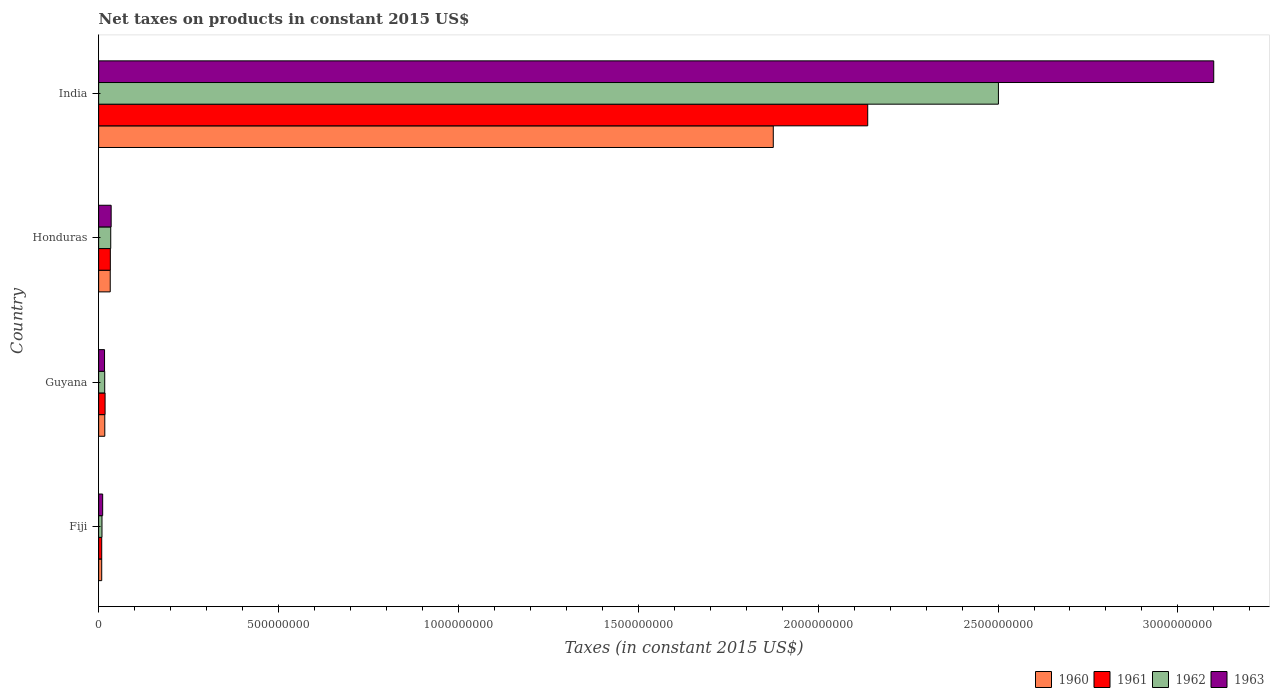How many groups of bars are there?
Offer a terse response. 4. Are the number of bars per tick equal to the number of legend labels?
Your answer should be very brief. Yes. Are the number of bars on each tick of the Y-axis equal?
Provide a succinct answer. Yes. How many bars are there on the 1st tick from the top?
Provide a short and direct response. 4. How many bars are there on the 3rd tick from the bottom?
Make the answer very short. 4. What is the label of the 3rd group of bars from the top?
Provide a succinct answer. Guyana. In how many cases, is the number of bars for a given country not equal to the number of legend labels?
Give a very brief answer. 0. What is the net taxes on products in 1963 in India?
Your response must be concise. 3.10e+09. Across all countries, what is the maximum net taxes on products in 1961?
Provide a succinct answer. 2.14e+09. Across all countries, what is the minimum net taxes on products in 1962?
Your response must be concise. 9.32e+06. In which country was the net taxes on products in 1960 maximum?
Your answer should be very brief. India. In which country was the net taxes on products in 1960 minimum?
Offer a very short reply. Fiji. What is the total net taxes on products in 1960 in the graph?
Offer a very short reply. 1.93e+09. What is the difference between the net taxes on products in 1962 in Guyana and that in India?
Make the answer very short. -2.48e+09. What is the difference between the net taxes on products in 1962 in Guyana and the net taxes on products in 1961 in Fiji?
Make the answer very short. 8.35e+06. What is the average net taxes on products in 1962 per country?
Your answer should be compact. 6.40e+08. What is the difference between the net taxes on products in 1963 and net taxes on products in 1961 in Honduras?
Your response must be concise. 2.30e+06. In how many countries, is the net taxes on products in 1962 greater than 1100000000 US$?
Offer a very short reply. 1. What is the ratio of the net taxes on products in 1963 in Fiji to that in Honduras?
Ensure brevity in your answer.  0.32. Is the net taxes on products in 1960 in Guyana less than that in Honduras?
Your answer should be compact. Yes. What is the difference between the highest and the second highest net taxes on products in 1962?
Your response must be concise. 2.47e+09. What is the difference between the highest and the lowest net taxes on products in 1963?
Provide a short and direct response. 3.09e+09. In how many countries, is the net taxes on products in 1962 greater than the average net taxes on products in 1962 taken over all countries?
Give a very brief answer. 1. Is the sum of the net taxes on products in 1961 in Fiji and Guyana greater than the maximum net taxes on products in 1963 across all countries?
Offer a terse response. No. Is it the case that in every country, the sum of the net taxes on products in 1961 and net taxes on products in 1962 is greater than the sum of net taxes on products in 1960 and net taxes on products in 1963?
Your response must be concise. No. What does the 4th bar from the top in India represents?
Ensure brevity in your answer.  1960. How many countries are there in the graph?
Your response must be concise. 4. Does the graph contain any zero values?
Make the answer very short. No. Does the graph contain grids?
Offer a terse response. No. How many legend labels are there?
Provide a succinct answer. 4. How are the legend labels stacked?
Give a very brief answer. Horizontal. What is the title of the graph?
Provide a succinct answer. Net taxes on products in constant 2015 US$. What is the label or title of the X-axis?
Provide a succinct answer. Taxes (in constant 2015 US$). What is the Taxes (in constant 2015 US$) of 1960 in Fiji?
Your answer should be compact. 8.56e+06. What is the Taxes (in constant 2015 US$) in 1961 in Fiji?
Offer a very short reply. 8.56e+06. What is the Taxes (in constant 2015 US$) in 1962 in Fiji?
Provide a short and direct response. 9.32e+06. What is the Taxes (in constant 2015 US$) in 1963 in Fiji?
Offer a very short reply. 1.12e+07. What is the Taxes (in constant 2015 US$) in 1960 in Guyana?
Your response must be concise. 1.71e+07. What is the Taxes (in constant 2015 US$) of 1961 in Guyana?
Offer a terse response. 1.79e+07. What is the Taxes (in constant 2015 US$) in 1962 in Guyana?
Your answer should be compact. 1.69e+07. What is the Taxes (in constant 2015 US$) of 1963 in Guyana?
Make the answer very short. 1.64e+07. What is the Taxes (in constant 2015 US$) of 1960 in Honduras?
Provide a short and direct response. 3.22e+07. What is the Taxes (in constant 2015 US$) of 1961 in Honduras?
Give a very brief answer. 3.25e+07. What is the Taxes (in constant 2015 US$) of 1962 in Honduras?
Offer a very short reply. 3.36e+07. What is the Taxes (in constant 2015 US$) of 1963 in Honduras?
Keep it short and to the point. 3.48e+07. What is the Taxes (in constant 2015 US$) in 1960 in India?
Provide a short and direct response. 1.88e+09. What is the Taxes (in constant 2015 US$) in 1961 in India?
Offer a terse response. 2.14e+09. What is the Taxes (in constant 2015 US$) of 1962 in India?
Keep it short and to the point. 2.50e+09. What is the Taxes (in constant 2015 US$) of 1963 in India?
Your answer should be very brief. 3.10e+09. Across all countries, what is the maximum Taxes (in constant 2015 US$) in 1960?
Give a very brief answer. 1.88e+09. Across all countries, what is the maximum Taxes (in constant 2015 US$) of 1961?
Keep it short and to the point. 2.14e+09. Across all countries, what is the maximum Taxes (in constant 2015 US$) in 1962?
Ensure brevity in your answer.  2.50e+09. Across all countries, what is the maximum Taxes (in constant 2015 US$) in 1963?
Your response must be concise. 3.10e+09. Across all countries, what is the minimum Taxes (in constant 2015 US$) in 1960?
Offer a terse response. 8.56e+06. Across all countries, what is the minimum Taxes (in constant 2015 US$) of 1961?
Your answer should be very brief. 8.56e+06. Across all countries, what is the minimum Taxes (in constant 2015 US$) of 1962?
Offer a very short reply. 9.32e+06. Across all countries, what is the minimum Taxes (in constant 2015 US$) in 1963?
Provide a succinct answer. 1.12e+07. What is the total Taxes (in constant 2015 US$) of 1960 in the graph?
Offer a terse response. 1.93e+09. What is the total Taxes (in constant 2015 US$) of 1961 in the graph?
Give a very brief answer. 2.20e+09. What is the total Taxes (in constant 2015 US$) of 1962 in the graph?
Your response must be concise. 2.56e+09. What is the total Taxes (in constant 2015 US$) in 1963 in the graph?
Offer a very short reply. 3.16e+09. What is the difference between the Taxes (in constant 2015 US$) of 1960 in Fiji and that in Guyana?
Provide a short and direct response. -8.59e+06. What is the difference between the Taxes (in constant 2015 US$) of 1961 in Fiji and that in Guyana?
Offer a very short reply. -9.34e+06. What is the difference between the Taxes (in constant 2015 US$) in 1962 in Fiji and that in Guyana?
Ensure brevity in your answer.  -7.60e+06. What is the difference between the Taxes (in constant 2015 US$) in 1963 in Fiji and that in Guyana?
Make the answer very short. -5.24e+06. What is the difference between the Taxes (in constant 2015 US$) of 1960 in Fiji and that in Honduras?
Keep it short and to the point. -2.37e+07. What is the difference between the Taxes (in constant 2015 US$) in 1961 in Fiji and that in Honduras?
Your answer should be very brief. -2.39e+07. What is the difference between the Taxes (in constant 2015 US$) of 1962 in Fiji and that in Honduras?
Your answer should be very brief. -2.43e+07. What is the difference between the Taxes (in constant 2015 US$) in 1963 in Fiji and that in Honduras?
Offer a terse response. -2.36e+07. What is the difference between the Taxes (in constant 2015 US$) of 1960 in Fiji and that in India?
Provide a short and direct response. -1.87e+09. What is the difference between the Taxes (in constant 2015 US$) of 1961 in Fiji and that in India?
Give a very brief answer. -2.13e+09. What is the difference between the Taxes (in constant 2015 US$) of 1962 in Fiji and that in India?
Your response must be concise. -2.49e+09. What is the difference between the Taxes (in constant 2015 US$) of 1963 in Fiji and that in India?
Keep it short and to the point. -3.09e+09. What is the difference between the Taxes (in constant 2015 US$) of 1960 in Guyana and that in Honduras?
Your answer should be very brief. -1.51e+07. What is the difference between the Taxes (in constant 2015 US$) of 1961 in Guyana and that in Honduras?
Your answer should be compact. -1.46e+07. What is the difference between the Taxes (in constant 2015 US$) in 1962 in Guyana and that in Honduras?
Your response must be concise. -1.67e+07. What is the difference between the Taxes (in constant 2015 US$) in 1963 in Guyana and that in Honduras?
Your answer should be compact. -1.84e+07. What is the difference between the Taxes (in constant 2015 US$) in 1960 in Guyana and that in India?
Your answer should be very brief. -1.86e+09. What is the difference between the Taxes (in constant 2015 US$) in 1961 in Guyana and that in India?
Ensure brevity in your answer.  -2.12e+09. What is the difference between the Taxes (in constant 2015 US$) of 1962 in Guyana and that in India?
Keep it short and to the point. -2.48e+09. What is the difference between the Taxes (in constant 2015 US$) in 1963 in Guyana and that in India?
Keep it short and to the point. -3.08e+09. What is the difference between the Taxes (in constant 2015 US$) of 1960 in Honduras and that in India?
Keep it short and to the point. -1.84e+09. What is the difference between the Taxes (in constant 2015 US$) of 1961 in Honduras and that in India?
Keep it short and to the point. -2.11e+09. What is the difference between the Taxes (in constant 2015 US$) of 1962 in Honduras and that in India?
Offer a very short reply. -2.47e+09. What is the difference between the Taxes (in constant 2015 US$) of 1963 in Honduras and that in India?
Your response must be concise. -3.06e+09. What is the difference between the Taxes (in constant 2015 US$) in 1960 in Fiji and the Taxes (in constant 2015 US$) in 1961 in Guyana?
Your answer should be compact. -9.34e+06. What is the difference between the Taxes (in constant 2015 US$) of 1960 in Fiji and the Taxes (in constant 2015 US$) of 1962 in Guyana?
Offer a terse response. -8.35e+06. What is the difference between the Taxes (in constant 2015 US$) in 1960 in Fiji and the Taxes (in constant 2015 US$) in 1963 in Guyana?
Make the answer very short. -7.89e+06. What is the difference between the Taxes (in constant 2015 US$) in 1961 in Fiji and the Taxes (in constant 2015 US$) in 1962 in Guyana?
Give a very brief answer. -8.35e+06. What is the difference between the Taxes (in constant 2015 US$) of 1961 in Fiji and the Taxes (in constant 2015 US$) of 1963 in Guyana?
Your answer should be very brief. -7.89e+06. What is the difference between the Taxes (in constant 2015 US$) in 1962 in Fiji and the Taxes (in constant 2015 US$) in 1963 in Guyana?
Provide a succinct answer. -7.13e+06. What is the difference between the Taxes (in constant 2015 US$) of 1960 in Fiji and the Taxes (in constant 2015 US$) of 1961 in Honduras?
Your answer should be very brief. -2.39e+07. What is the difference between the Taxes (in constant 2015 US$) in 1960 in Fiji and the Taxes (in constant 2015 US$) in 1962 in Honduras?
Your answer should be compact. -2.51e+07. What is the difference between the Taxes (in constant 2015 US$) in 1960 in Fiji and the Taxes (in constant 2015 US$) in 1963 in Honduras?
Give a very brief answer. -2.62e+07. What is the difference between the Taxes (in constant 2015 US$) of 1961 in Fiji and the Taxes (in constant 2015 US$) of 1962 in Honduras?
Offer a very short reply. -2.51e+07. What is the difference between the Taxes (in constant 2015 US$) of 1961 in Fiji and the Taxes (in constant 2015 US$) of 1963 in Honduras?
Provide a succinct answer. -2.62e+07. What is the difference between the Taxes (in constant 2015 US$) in 1962 in Fiji and the Taxes (in constant 2015 US$) in 1963 in Honduras?
Provide a succinct answer. -2.55e+07. What is the difference between the Taxes (in constant 2015 US$) in 1960 in Fiji and the Taxes (in constant 2015 US$) in 1961 in India?
Make the answer very short. -2.13e+09. What is the difference between the Taxes (in constant 2015 US$) of 1960 in Fiji and the Taxes (in constant 2015 US$) of 1962 in India?
Ensure brevity in your answer.  -2.49e+09. What is the difference between the Taxes (in constant 2015 US$) of 1960 in Fiji and the Taxes (in constant 2015 US$) of 1963 in India?
Give a very brief answer. -3.09e+09. What is the difference between the Taxes (in constant 2015 US$) of 1961 in Fiji and the Taxes (in constant 2015 US$) of 1962 in India?
Offer a very short reply. -2.49e+09. What is the difference between the Taxes (in constant 2015 US$) in 1961 in Fiji and the Taxes (in constant 2015 US$) in 1963 in India?
Keep it short and to the point. -3.09e+09. What is the difference between the Taxes (in constant 2015 US$) of 1962 in Fiji and the Taxes (in constant 2015 US$) of 1963 in India?
Give a very brief answer. -3.09e+09. What is the difference between the Taxes (in constant 2015 US$) of 1960 in Guyana and the Taxes (in constant 2015 US$) of 1961 in Honduras?
Your response must be concise. -1.54e+07. What is the difference between the Taxes (in constant 2015 US$) in 1960 in Guyana and the Taxes (in constant 2015 US$) in 1962 in Honduras?
Your answer should be very brief. -1.65e+07. What is the difference between the Taxes (in constant 2015 US$) of 1960 in Guyana and the Taxes (in constant 2015 US$) of 1963 in Honduras?
Your answer should be very brief. -1.77e+07. What is the difference between the Taxes (in constant 2015 US$) of 1961 in Guyana and the Taxes (in constant 2015 US$) of 1962 in Honduras?
Ensure brevity in your answer.  -1.57e+07. What is the difference between the Taxes (in constant 2015 US$) of 1961 in Guyana and the Taxes (in constant 2015 US$) of 1963 in Honduras?
Offer a terse response. -1.69e+07. What is the difference between the Taxes (in constant 2015 US$) in 1962 in Guyana and the Taxes (in constant 2015 US$) in 1963 in Honduras?
Your answer should be very brief. -1.79e+07. What is the difference between the Taxes (in constant 2015 US$) of 1960 in Guyana and the Taxes (in constant 2015 US$) of 1961 in India?
Your answer should be compact. -2.12e+09. What is the difference between the Taxes (in constant 2015 US$) of 1960 in Guyana and the Taxes (in constant 2015 US$) of 1962 in India?
Your response must be concise. -2.48e+09. What is the difference between the Taxes (in constant 2015 US$) in 1960 in Guyana and the Taxes (in constant 2015 US$) in 1963 in India?
Offer a terse response. -3.08e+09. What is the difference between the Taxes (in constant 2015 US$) of 1961 in Guyana and the Taxes (in constant 2015 US$) of 1962 in India?
Provide a short and direct response. -2.48e+09. What is the difference between the Taxes (in constant 2015 US$) of 1961 in Guyana and the Taxes (in constant 2015 US$) of 1963 in India?
Ensure brevity in your answer.  -3.08e+09. What is the difference between the Taxes (in constant 2015 US$) of 1962 in Guyana and the Taxes (in constant 2015 US$) of 1963 in India?
Provide a short and direct response. -3.08e+09. What is the difference between the Taxes (in constant 2015 US$) of 1960 in Honduras and the Taxes (in constant 2015 US$) of 1961 in India?
Your response must be concise. -2.11e+09. What is the difference between the Taxes (in constant 2015 US$) in 1960 in Honduras and the Taxes (in constant 2015 US$) in 1962 in India?
Give a very brief answer. -2.47e+09. What is the difference between the Taxes (in constant 2015 US$) of 1960 in Honduras and the Taxes (in constant 2015 US$) of 1963 in India?
Your answer should be compact. -3.07e+09. What is the difference between the Taxes (in constant 2015 US$) of 1961 in Honduras and the Taxes (in constant 2015 US$) of 1962 in India?
Keep it short and to the point. -2.47e+09. What is the difference between the Taxes (in constant 2015 US$) in 1961 in Honduras and the Taxes (in constant 2015 US$) in 1963 in India?
Offer a terse response. -3.07e+09. What is the difference between the Taxes (in constant 2015 US$) in 1962 in Honduras and the Taxes (in constant 2015 US$) in 1963 in India?
Provide a succinct answer. -3.07e+09. What is the average Taxes (in constant 2015 US$) of 1960 per country?
Make the answer very short. 4.83e+08. What is the average Taxes (in constant 2015 US$) in 1961 per country?
Make the answer very short. 5.49e+08. What is the average Taxes (in constant 2015 US$) of 1962 per country?
Make the answer very short. 6.40e+08. What is the average Taxes (in constant 2015 US$) of 1963 per country?
Ensure brevity in your answer.  7.91e+08. What is the difference between the Taxes (in constant 2015 US$) in 1960 and Taxes (in constant 2015 US$) in 1962 in Fiji?
Give a very brief answer. -7.56e+05. What is the difference between the Taxes (in constant 2015 US$) of 1960 and Taxes (in constant 2015 US$) of 1963 in Fiji?
Provide a short and direct response. -2.64e+06. What is the difference between the Taxes (in constant 2015 US$) in 1961 and Taxes (in constant 2015 US$) in 1962 in Fiji?
Provide a succinct answer. -7.56e+05. What is the difference between the Taxes (in constant 2015 US$) of 1961 and Taxes (in constant 2015 US$) of 1963 in Fiji?
Your response must be concise. -2.64e+06. What is the difference between the Taxes (in constant 2015 US$) of 1962 and Taxes (in constant 2015 US$) of 1963 in Fiji?
Ensure brevity in your answer.  -1.89e+06. What is the difference between the Taxes (in constant 2015 US$) in 1960 and Taxes (in constant 2015 US$) in 1961 in Guyana?
Ensure brevity in your answer.  -7.58e+05. What is the difference between the Taxes (in constant 2015 US$) in 1960 and Taxes (in constant 2015 US$) in 1962 in Guyana?
Your answer should be very brief. 2.33e+05. What is the difference between the Taxes (in constant 2015 US$) in 1960 and Taxes (in constant 2015 US$) in 1963 in Guyana?
Offer a very short reply. 7.00e+05. What is the difference between the Taxes (in constant 2015 US$) in 1961 and Taxes (in constant 2015 US$) in 1962 in Guyana?
Provide a succinct answer. 9.92e+05. What is the difference between the Taxes (in constant 2015 US$) in 1961 and Taxes (in constant 2015 US$) in 1963 in Guyana?
Your response must be concise. 1.46e+06. What is the difference between the Taxes (in constant 2015 US$) in 1962 and Taxes (in constant 2015 US$) in 1963 in Guyana?
Give a very brief answer. 4.67e+05. What is the difference between the Taxes (in constant 2015 US$) in 1960 and Taxes (in constant 2015 US$) in 1961 in Honduras?
Ensure brevity in your answer.  -2.50e+05. What is the difference between the Taxes (in constant 2015 US$) of 1960 and Taxes (in constant 2015 US$) of 1962 in Honduras?
Your answer should be compact. -1.40e+06. What is the difference between the Taxes (in constant 2015 US$) in 1960 and Taxes (in constant 2015 US$) in 1963 in Honduras?
Provide a short and direct response. -2.55e+06. What is the difference between the Taxes (in constant 2015 US$) of 1961 and Taxes (in constant 2015 US$) of 1962 in Honduras?
Your answer should be very brief. -1.15e+06. What is the difference between the Taxes (in constant 2015 US$) in 1961 and Taxes (in constant 2015 US$) in 1963 in Honduras?
Make the answer very short. -2.30e+06. What is the difference between the Taxes (in constant 2015 US$) in 1962 and Taxes (in constant 2015 US$) in 1963 in Honduras?
Ensure brevity in your answer.  -1.15e+06. What is the difference between the Taxes (in constant 2015 US$) in 1960 and Taxes (in constant 2015 US$) in 1961 in India?
Your answer should be compact. -2.63e+08. What is the difference between the Taxes (in constant 2015 US$) in 1960 and Taxes (in constant 2015 US$) in 1962 in India?
Keep it short and to the point. -6.26e+08. What is the difference between the Taxes (in constant 2015 US$) of 1960 and Taxes (in constant 2015 US$) of 1963 in India?
Your answer should be very brief. -1.22e+09. What is the difference between the Taxes (in constant 2015 US$) in 1961 and Taxes (in constant 2015 US$) in 1962 in India?
Your answer should be compact. -3.63e+08. What is the difference between the Taxes (in constant 2015 US$) of 1961 and Taxes (in constant 2015 US$) of 1963 in India?
Keep it short and to the point. -9.62e+08. What is the difference between the Taxes (in constant 2015 US$) in 1962 and Taxes (in constant 2015 US$) in 1963 in India?
Make the answer very short. -5.99e+08. What is the ratio of the Taxes (in constant 2015 US$) in 1960 in Fiji to that in Guyana?
Give a very brief answer. 0.5. What is the ratio of the Taxes (in constant 2015 US$) in 1961 in Fiji to that in Guyana?
Give a very brief answer. 0.48. What is the ratio of the Taxes (in constant 2015 US$) in 1962 in Fiji to that in Guyana?
Give a very brief answer. 0.55. What is the ratio of the Taxes (in constant 2015 US$) in 1963 in Fiji to that in Guyana?
Give a very brief answer. 0.68. What is the ratio of the Taxes (in constant 2015 US$) of 1960 in Fiji to that in Honduras?
Your answer should be very brief. 0.27. What is the ratio of the Taxes (in constant 2015 US$) in 1961 in Fiji to that in Honduras?
Your answer should be compact. 0.26. What is the ratio of the Taxes (in constant 2015 US$) in 1962 in Fiji to that in Honduras?
Offer a very short reply. 0.28. What is the ratio of the Taxes (in constant 2015 US$) in 1963 in Fiji to that in Honduras?
Keep it short and to the point. 0.32. What is the ratio of the Taxes (in constant 2015 US$) in 1960 in Fiji to that in India?
Your answer should be compact. 0. What is the ratio of the Taxes (in constant 2015 US$) of 1961 in Fiji to that in India?
Your answer should be very brief. 0. What is the ratio of the Taxes (in constant 2015 US$) of 1962 in Fiji to that in India?
Ensure brevity in your answer.  0. What is the ratio of the Taxes (in constant 2015 US$) of 1963 in Fiji to that in India?
Offer a terse response. 0. What is the ratio of the Taxes (in constant 2015 US$) of 1960 in Guyana to that in Honduras?
Provide a succinct answer. 0.53. What is the ratio of the Taxes (in constant 2015 US$) of 1961 in Guyana to that in Honduras?
Your response must be concise. 0.55. What is the ratio of the Taxes (in constant 2015 US$) of 1962 in Guyana to that in Honduras?
Make the answer very short. 0.5. What is the ratio of the Taxes (in constant 2015 US$) in 1963 in Guyana to that in Honduras?
Provide a succinct answer. 0.47. What is the ratio of the Taxes (in constant 2015 US$) of 1960 in Guyana to that in India?
Offer a terse response. 0.01. What is the ratio of the Taxes (in constant 2015 US$) of 1961 in Guyana to that in India?
Offer a very short reply. 0.01. What is the ratio of the Taxes (in constant 2015 US$) of 1962 in Guyana to that in India?
Offer a very short reply. 0.01. What is the ratio of the Taxes (in constant 2015 US$) of 1963 in Guyana to that in India?
Your response must be concise. 0.01. What is the ratio of the Taxes (in constant 2015 US$) in 1960 in Honduras to that in India?
Provide a short and direct response. 0.02. What is the ratio of the Taxes (in constant 2015 US$) in 1961 in Honduras to that in India?
Provide a succinct answer. 0.02. What is the ratio of the Taxes (in constant 2015 US$) of 1962 in Honduras to that in India?
Offer a terse response. 0.01. What is the ratio of the Taxes (in constant 2015 US$) of 1963 in Honduras to that in India?
Your response must be concise. 0.01. What is the difference between the highest and the second highest Taxes (in constant 2015 US$) in 1960?
Your response must be concise. 1.84e+09. What is the difference between the highest and the second highest Taxes (in constant 2015 US$) in 1961?
Make the answer very short. 2.11e+09. What is the difference between the highest and the second highest Taxes (in constant 2015 US$) of 1962?
Provide a succinct answer. 2.47e+09. What is the difference between the highest and the second highest Taxes (in constant 2015 US$) in 1963?
Provide a short and direct response. 3.06e+09. What is the difference between the highest and the lowest Taxes (in constant 2015 US$) in 1960?
Provide a short and direct response. 1.87e+09. What is the difference between the highest and the lowest Taxes (in constant 2015 US$) in 1961?
Your answer should be compact. 2.13e+09. What is the difference between the highest and the lowest Taxes (in constant 2015 US$) in 1962?
Your response must be concise. 2.49e+09. What is the difference between the highest and the lowest Taxes (in constant 2015 US$) in 1963?
Ensure brevity in your answer.  3.09e+09. 